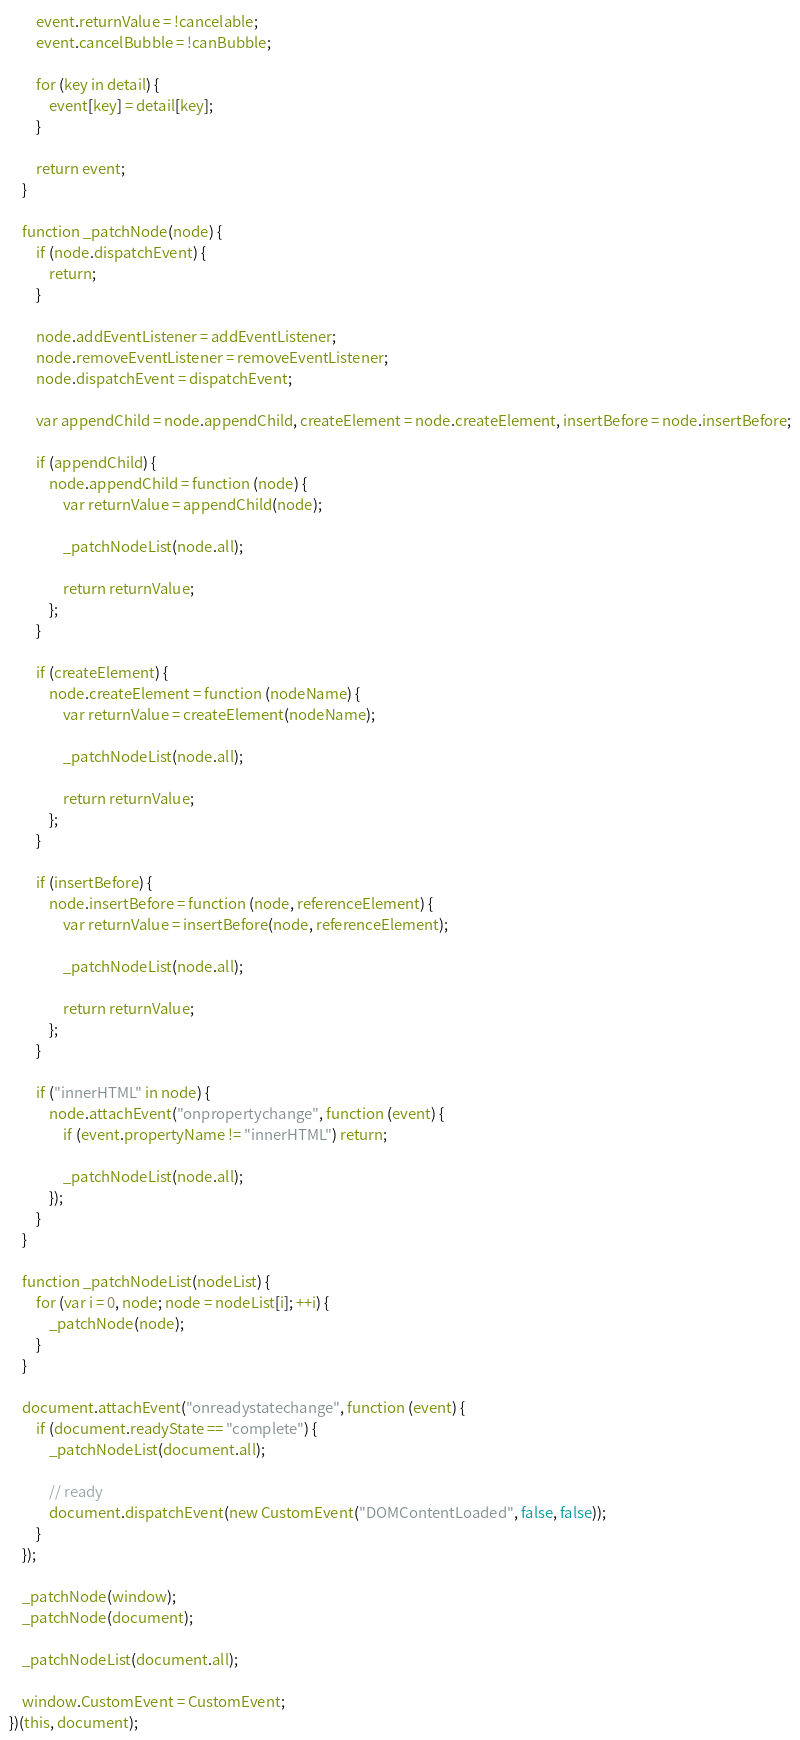Convert code to text. <code><loc_0><loc_0><loc_500><loc_500><_JavaScript_>		event.returnValue = !cancelable;
		event.cancelBubble = !canBubble;

		for (key in detail) {
			event[key] = detail[key];
		}

		return event;
	}

	function _patchNode(node) {
		if (node.dispatchEvent) {
			return;
		}

		node.addEventListener = addEventListener;
		node.removeEventListener = removeEventListener;
		node.dispatchEvent = dispatchEvent;

		var appendChild = node.appendChild, createElement = node.createElement, insertBefore = node.insertBefore;

		if (appendChild) {
			node.appendChild = function (node) {
				var returnValue = appendChild(node);

				_patchNodeList(node.all);

				return returnValue;
			};
		}

		if (createElement) {
			node.createElement = function (nodeName) {
				var returnValue = createElement(nodeName);

				_patchNodeList(node.all);

				return returnValue;
			};
		}

		if (insertBefore) {
			node.insertBefore = function (node, referenceElement) {
				var returnValue = insertBefore(node, referenceElement);

				_patchNodeList(node.all);

				return returnValue;
			};
		}

		if ("innerHTML" in node) {
			node.attachEvent("onpropertychange", function (event) {
				if (event.propertyName != "innerHTML") return;

				_patchNodeList(node.all);
			});
		}
	}

	function _patchNodeList(nodeList) {
		for (var i = 0, node; node = nodeList[i]; ++i) {
			_patchNode(node);
		}
	}

	document.attachEvent("onreadystatechange", function (event) {
		if (document.readyState == "complete") {
			_patchNodeList(document.all);

			// ready
			document.dispatchEvent(new CustomEvent("DOMContentLoaded", false, false));
		}
	});

	_patchNode(window);
	_patchNode(document);

	_patchNodeList(document.all);

	window.CustomEvent = CustomEvent;
})(this, document);</code> 